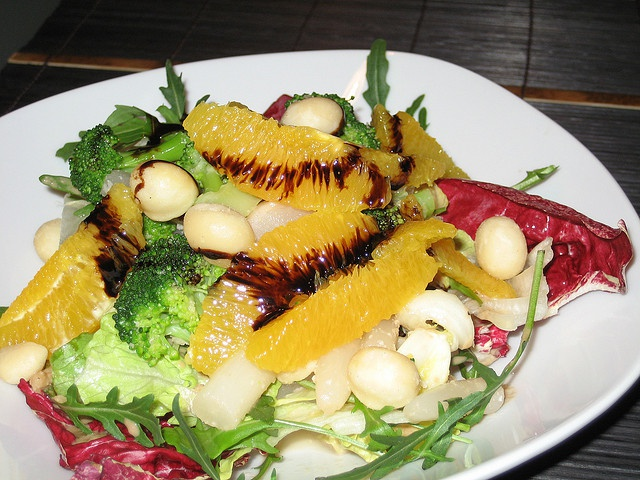Describe the objects in this image and their specific colors. I can see dining table in lightgray, black, khaki, orange, and darkgreen tones, orange in black, orange, maroon, and brown tones, orange in black, gold, and olive tones, orange in black and gold tones, and orange in black, orange, tan, maroon, and red tones in this image. 